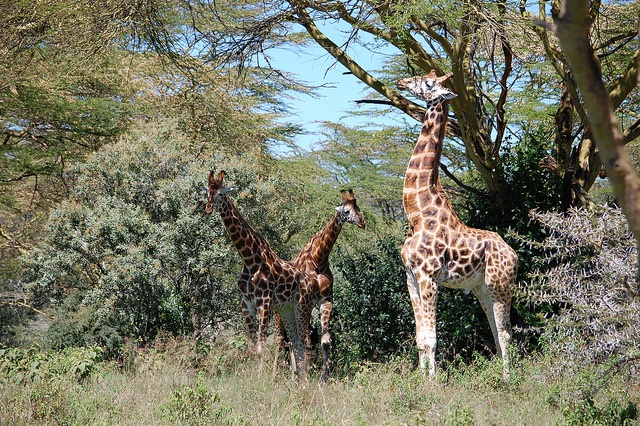Describe the objects in this image and their specific colors. I can see giraffe in darkgreen, white, gray, tan, and black tones, giraffe in darkgreen, black, gray, and maroon tones, and giraffe in darkgreen, black, gray, and maroon tones in this image. 